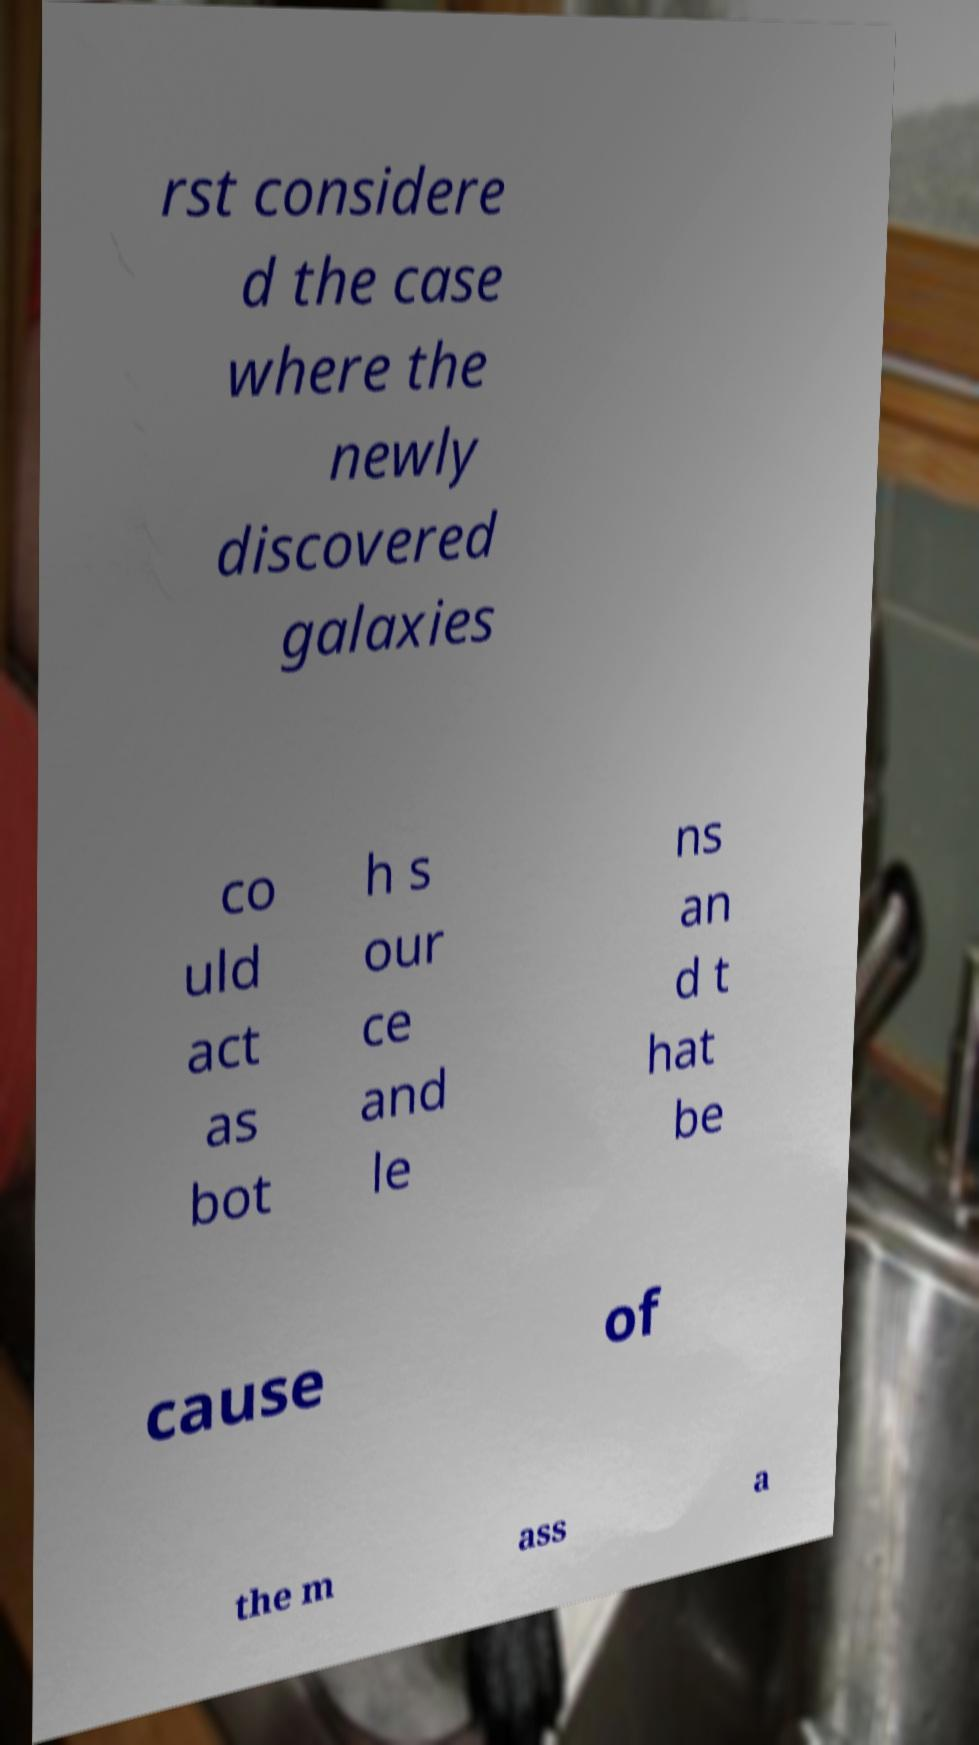Please identify and transcribe the text found in this image. rst considere d the case where the newly discovered galaxies co uld act as bot h s our ce and le ns an d t hat be cause of the m ass a 